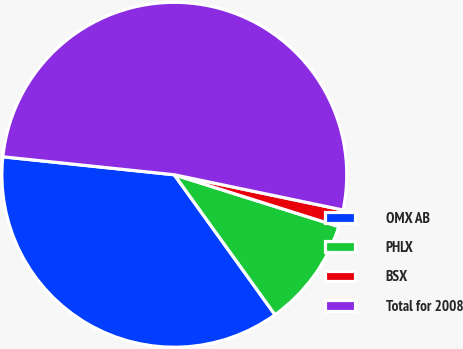<chart> <loc_0><loc_0><loc_500><loc_500><pie_chart><fcel>OMX AB<fcel>PHLX<fcel>BSX<fcel>Total for 2008<nl><fcel>36.59%<fcel>10.22%<fcel>1.58%<fcel>51.62%<nl></chart> 